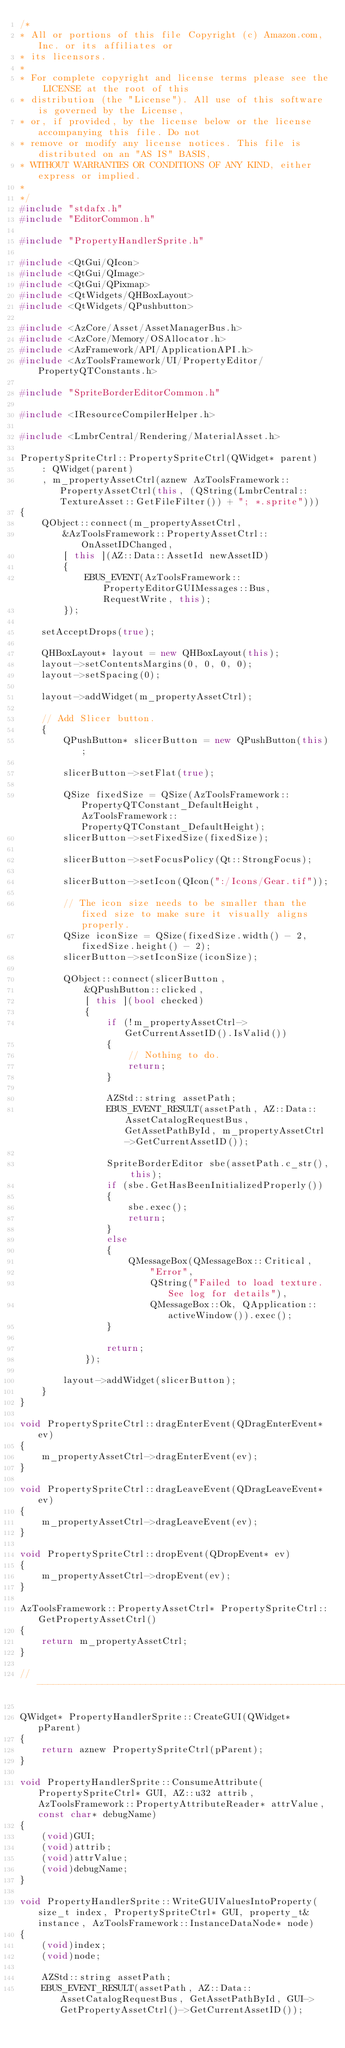<code> <loc_0><loc_0><loc_500><loc_500><_C++_>/*
* All or portions of this file Copyright (c) Amazon.com, Inc. or its affiliates or
* its licensors.
*
* For complete copyright and license terms please see the LICENSE at the root of this
* distribution (the "License"). All use of this software is governed by the License,
* or, if provided, by the license below or the license accompanying this file. Do not
* remove or modify any license notices. This file is distributed on an "AS IS" BASIS,
* WITHOUT WARRANTIES OR CONDITIONS OF ANY KIND, either express or implied.
*
*/
#include "stdafx.h"
#include "EditorCommon.h"

#include "PropertyHandlerSprite.h"

#include <QtGui/QIcon>
#include <QtGui/QImage>
#include <QtGui/QPixmap>
#include <QtWidgets/QHBoxLayout>
#include <QtWidgets/QPushbutton>

#include <AzCore/Asset/AssetManagerBus.h>
#include <AzCore/Memory/OSAllocator.h>
#include <AzFramework/API/ApplicationAPI.h>
#include <AzToolsFramework/UI/PropertyEditor/PropertyQTConstants.h>

#include "SpriteBorderEditorCommon.h"

#include <IResourceCompilerHelper.h>

#include <LmbrCentral/Rendering/MaterialAsset.h>

PropertySpriteCtrl::PropertySpriteCtrl(QWidget* parent)
    : QWidget(parent)
    , m_propertyAssetCtrl(aznew AzToolsFramework::PropertyAssetCtrl(this, (QString(LmbrCentral::TextureAsset::GetFileFilter()) + "; *.sprite")))
{
    QObject::connect(m_propertyAssetCtrl,
        &AzToolsFramework::PropertyAssetCtrl::OnAssetIDChanged,
        [ this ](AZ::Data::AssetId newAssetID)
        {
            EBUS_EVENT(AzToolsFramework::PropertyEditorGUIMessages::Bus, RequestWrite, this);
        });

    setAcceptDrops(true);

    QHBoxLayout* layout = new QHBoxLayout(this);
    layout->setContentsMargins(0, 0, 0, 0);
    layout->setSpacing(0);

    layout->addWidget(m_propertyAssetCtrl);

    // Add Slicer button.
    {
        QPushButton* slicerButton = new QPushButton(this);

        slicerButton->setFlat(true);

        QSize fixedSize = QSize(AzToolsFramework::PropertyQTConstant_DefaultHeight, AzToolsFramework::PropertyQTConstant_DefaultHeight);
        slicerButton->setFixedSize(fixedSize);

        slicerButton->setFocusPolicy(Qt::StrongFocus);

        slicerButton->setIcon(QIcon(":/Icons/Gear.tif"));

        // The icon size needs to be smaller than the fixed size to make sure it visually aligns properly.
        QSize iconSize = QSize(fixedSize.width() - 2, fixedSize.height() - 2);
        slicerButton->setIconSize(iconSize);

        QObject::connect(slicerButton,
            &QPushButton::clicked,
            [ this ](bool checked)
            {
                if (!m_propertyAssetCtrl->GetCurrentAssetID().IsValid())
                {
                    // Nothing to do.
                    return;
                }

                AZStd::string assetPath;
                EBUS_EVENT_RESULT(assetPath, AZ::Data::AssetCatalogRequestBus, GetAssetPathById, m_propertyAssetCtrl->GetCurrentAssetID());

                SpriteBorderEditor sbe(assetPath.c_str(), this);
                if (sbe.GetHasBeenInitializedProperly())
                {
                    sbe.exec();
                    return;
                }
                else
                {
                    QMessageBox(QMessageBox::Critical,
                        "Error",
                        QString("Failed to load texture. See log for details"),
                        QMessageBox::Ok, QApplication::activeWindow()).exec();
                }

                return;
            });

        layout->addWidget(slicerButton);
    }
}

void PropertySpriteCtrl::dragEnterEvent(QDragEnterEvent* ev)
{
    m_propertyAssetCtrl->dragEnterEvent(ev);
}

void PropertySpriteCtrl::dragLeaveEvent(QDragLeaveEvent* ev)
{
    m_propertyAssetCtrl->dragLeaveEvent(ev);
}

void PropertySpriteCtrl::dropEvent(QDropEvent* ev)
{
    m_propertyAssetCtrl->dropEvent(ev);
}

AzToolsFramework::PropertyAssetCtrl* PropertySpriteCtrl::GetPropertyAssetCtrl()
{
    return m_propertyAssetCtrl;
}

//-------------------------------------------------------------------------------

QWidget* PropertyHandlerSprite::CreateGUI(QWidget* pParent)
{
    return aznew PropertySpriteCtrl(pParent);
}

void PropertyHandlerSprite::ConsumeAttribute(PropertySpriteCtrl* GUI, AZ::u32 attrib, AzToolsFramework::PropertyAttributeReader* attrValue, const char* debugName)
{
    (void)GUI;
    (void)attrib;
    (void)attrValue;
    (void)debugName;
}

void PropertyHandlerSprite::WriteGUIValuesIntoProperty(size_t index, PropertySpriteCtrl* GUI, property_t& instance, AzToolsFramework::InstanceDataNode* node)
{
    (void)index;
    (void)node;

    AZStd::string assetPath;
    EBUS_EVENT_RESULT(assetPath, AZ::Data::AssetCatalogRequestBus, GetAssetPathById, GUI->GetPropertyAssetCtrl()->GetCurrentAssetID());
</code> 